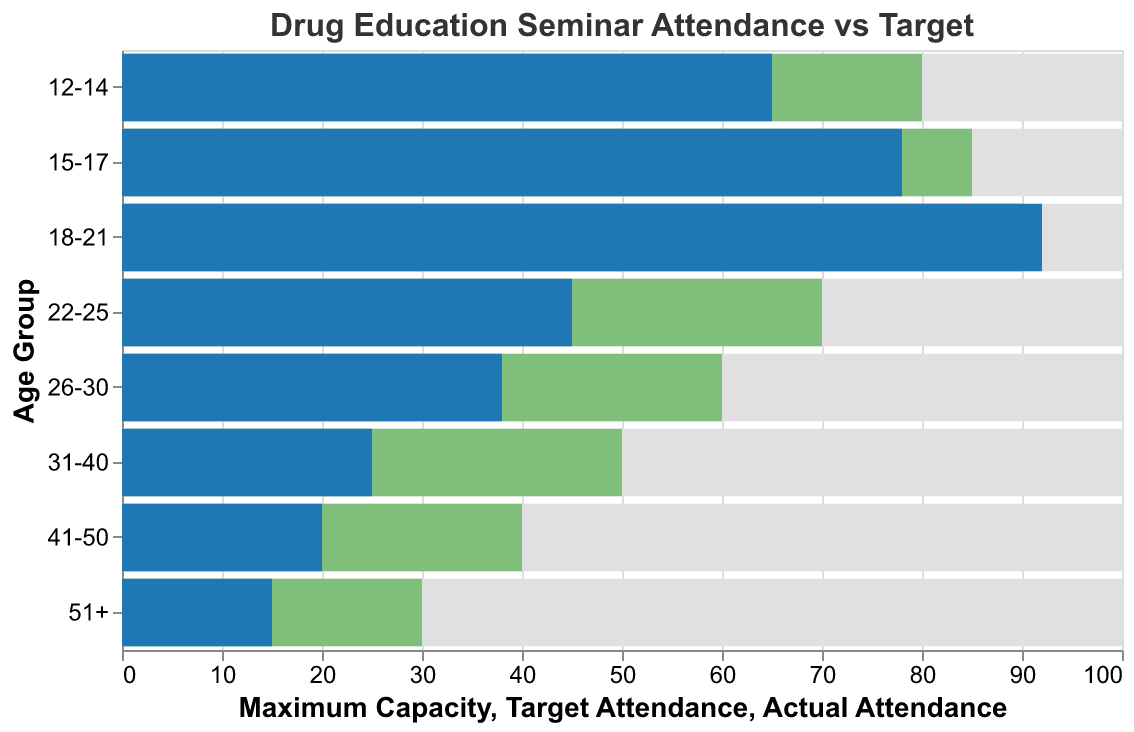What is the title of the chart? The title is typically provided at the top of the chart and indicates what the chart is about.
Answer: Drug Education Seminar Attendance vs Target Which age group has the highest actual attendance? By looking at the bar corresponding to the actual attendance, we can see which is the longest, signifying the highest attendance.
Answer: 18-21 Which age group has the lowest target attendance? By comparing the lengths of the bars representing target attendance, we can determine which one is the shortest.
Answer: 51+ How many age groups exceeded their target attendance? By visually comparing the actual attendance and target attendance bars for each age group, we count the number of cases where the actual attendance is greater than the target attendance.
Answer: 2 What is the actual attendance for the 15-17 age group? We can directly look at the blue bar for the 15-17 age group to read off the value indicated by the length of the bar.
Answer: 78 How much did the actual attendance for the 22-25 age group fall short of the target attendance? Take the target attendance and subtract the actual attendance for the 22-25 age group: 70 (target) - 45 (actual) = 25.
Answer: 25 Compare the actual attendance of the 12-14 age group to its target attendance. Visually compare the blue bar (actual attendance) and the green bar (target attendance) for the 12-14 age group to see the difference.
Answer: 65 actual vs. 80 target What is the gap between the maximum capacity and target attendance for the 26-30 age group? Subtract the target attendance from the maximum capacity for the 26-30 age group: 100 (maximum capacity) - 60 (target attendance) = 40.
Answer: 40 Did any age group reach their maximum capacity? We can determine this by checking if any bars indicating actual attendance extend to the maximum capacity limits.
Answer: No 